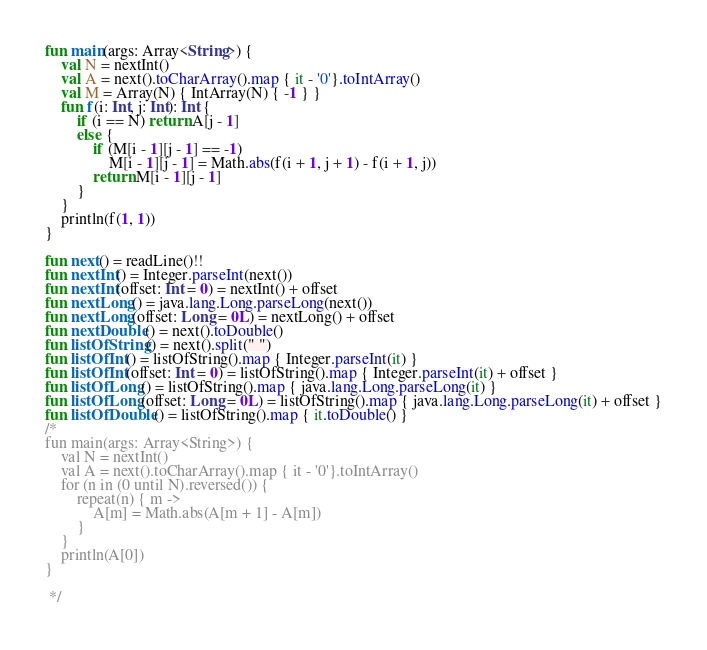Convert code to text. <code><loc_0><loc_0><loc_500><loc_500><_Kotlin_>fun main(args: Array<String>) {
    val N = nextInt()
    val A = next().toCharArray().map { it - '0'}.toIntArray()
    val M = Array(N) { IntArray(N) { -1 } }
    fun f(i: Int, j: Int): Int {
        if (i == N) return A[j - 1]
        else {
            if (M[i - 1][j - 1] == -1)
                M[i - 1][j - 1] = Math.abs(f(i + 1, j + 1) - f(i + 1, j))
            return M[i - 1][j - 1]
        }
    }
    println(f(1, 1))
}

fun next() = readLine()!!
fun nextInt() = Integer.parseInt(next())
fun nextInt(offset: Int = 0) = nextInt() + offset
fun nextLong() = java.lang.Long.parseLong(next())
fun nextLong(offset: Long = 0L) = nextLong() + offset
fun nextDouble() = next().toDouble()
fun listOfString() = next().split(" ")
fun listOfInt() = listOfString().map { Integer.parseInt(it) }
fun listOfInt(offset: Int = 0) = listOfString().map { Integer.parseInt(it) + offset }
fun listOfLong() = listOfString().map { java.lang.Long.parseLong(it) }
fun listOfLong(offset: Long = 0L) = listOfString().map { java.lang.Long.parseLong(it) + offset }
fun listOfDouble() = listOfString().map { it.toDouble() }
/*
fun main(args: Array<String>) {
    val N = nextInt()
    val A = next().toCharArray().map { it - '0'}.toIntArray()
    for (n in (0 until N).reversed()) {
        repeat(n) { m ->
            A[m] = Math.abs(A[m + 1] - A[m])
        }
    }
    println(A[0])
}

 */</code> 